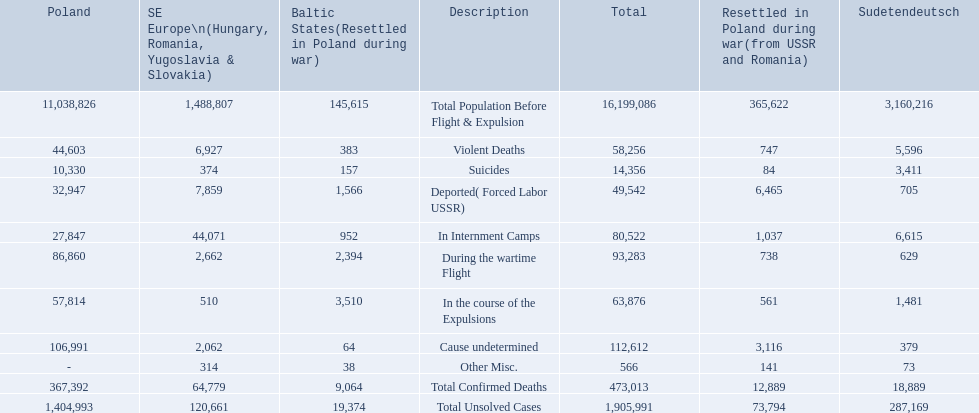What were the total number of confirmed deaths? 473,013. Of these, how many were violent? 58,256. What were all of the types of deaths? Violent Deaths, Suicides, Deported( Forced Labor USSR), In Internment Camps, During the wartime Flight, In the course of the Expulsions, Cause undetermined, Other Misc. And their totals in the baltic states? 383, 157, 1,566, 952, 2,394, 3,510, 64, 38. Give me the full table as a dictionary. {'header': ['Poland', 'SE Europe\\n(Hungary, Romania, Yugoslavia & Slovakia)', 'Baltic States(Resettled in Poland during war)', 'Description', 'Total', 'Resettled in Poland during war(from USSR and Romania)', 'Sudetendeutsch'], 'rows': [['11,038,826', '1,488,807', '145,615', 'Total Population Before Flight & Expulsion', '16,199,086', '365,622', '3,160,216'], ['44,603', '6,927', '383', 'Violent Deaths', '58,256', '747', '5,596'], ['10,330', '374', '157', 'Suicides', '14,356', '84', '3,411'], ['32,947', '7,859', '1,566', 'Deported( Forced Labor USSR)', '49,542', '6,465', '705'], ['27,847', '44,071', '952', 'In Internment Camps', '80,522', '1,037', '6,615'], ['86,860', '2,662', '2,394', 'During the wartime Flight', '93,283', '738', '629'], ['57,814', '510', '3,510', 'In the course of the Expulsions', '63,876', '561', '1,481'], ['106,991', '2,062', '64', 'Cause undetermined', '112,612', '3,116', '379'], ['-', '314', '38', 'Other Misc.', '566', '141', '73'], ['367,392', '64,779', '9,064', 'Total Confirmed Deaths', '473,013', '12,889', '18,889'], ['1,404,993', '120,661', '19,374', 'Total Unsolved Cases', '1,905,991', '73,794', '287,169']]} Were more deaths in the baltic states caused by undetermined causes or misc.? Cause undetermined. 